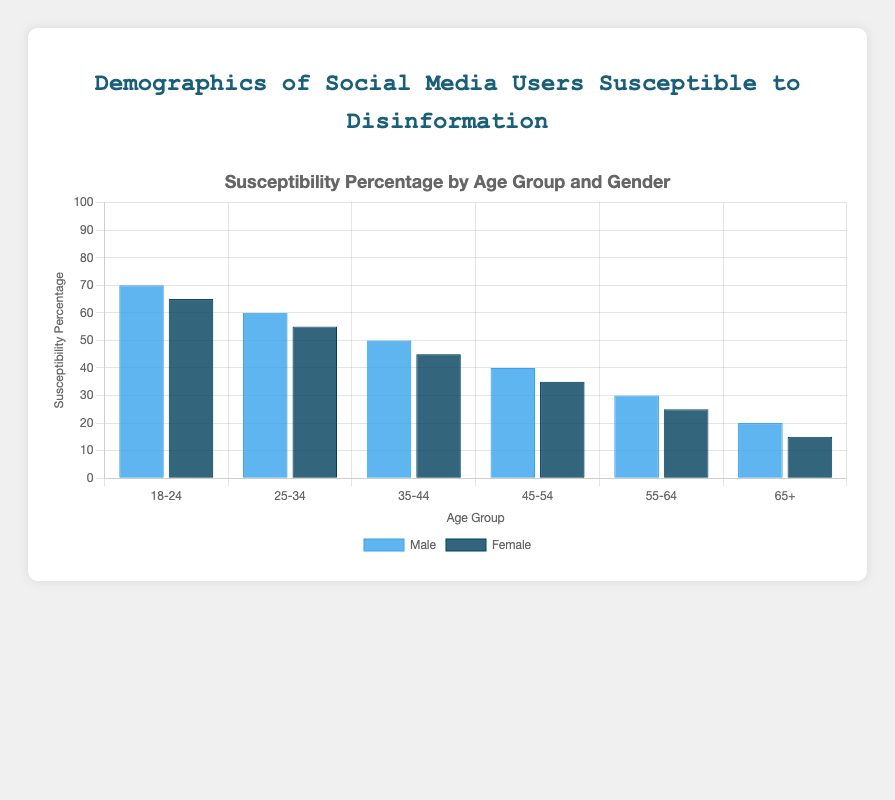Which age group has the highest susceptibility percentage among males? To answer this question, look at the height of the blue bars representing males. The 18-24 age group has the highest bar at a susceptibility percentage of 70.
Answer: 18-24 Compare the susceptibility percentage between males and females in the 25-34 age group. Find the two bars corresponding to the 25-34 age group. The height of the blue bar (males) is 60, and the height of the dark blue bar (females) is 55. Males have a higher susceptibility percentage than females in this age group.
Answer: Males What is the difference in susceptibility percentage between the 18-24 and 35-44 age groups for females? Look at the dark blue bars for the 18-24 and 35-44 age groups. The susceptibility percentage for females in the 18-24 age group is 65, and for the 35-44 age group, it is 45. The difference is 65 - 45 = 20.
Answer: 20 What is the average susceptibility percentage of males across all age groups? Sum all susceptibility percentages for males (70 + 60 + 50 + 40 + 30 + 20) and divide by the number of age groups, which is 6. So, (70 + 60 + 50 + 40 + 30 + 20) / 6 = 45.
Answer: 45 Which gender shows a greater decline in susceptibility percentage from the 18-24 to the 65+ age group? Calculate the decline for each gender. For males, the decline is 70 (18-24) - 20 (65+), which is 50. For females, the decline is 65 (18-24) - 15 (65+), which is 50. Both genders show the same decline.
Answer: Both In which age group is the susceptibility percentage the same for both genders? Look at the heights of the bars and compare them across age groups. The heights differ across all groups, so no age group has the same susceptibility percentage for both genders.
Answer: None What is the total susceptibility percentage for females in the 55-64 and 65+ age groups combined? Add the susceptibility percentages for females in the 55-64 and 65+ age groups: 25 (55-64) + 15 (65+) = 40.
Answer: 40 Among all age groups, which specific group and gender combination has the lowest susceptibility percentage? Identify the shortest bar in the chart. For females in the 65+ age group, the susceptibility percentage is 15, which is the lowest overall.
Answer: Females, 65+ Which age group shows the largest gender difference in susceptibility percentage? Calculate the difference for each age group by subtracting the female percentage from the male percentage. The largest difference is seen in 18-24 (70 - 65 = 5). None of the age groups exhibit a higher difference than 5.
Answer: 18-24 